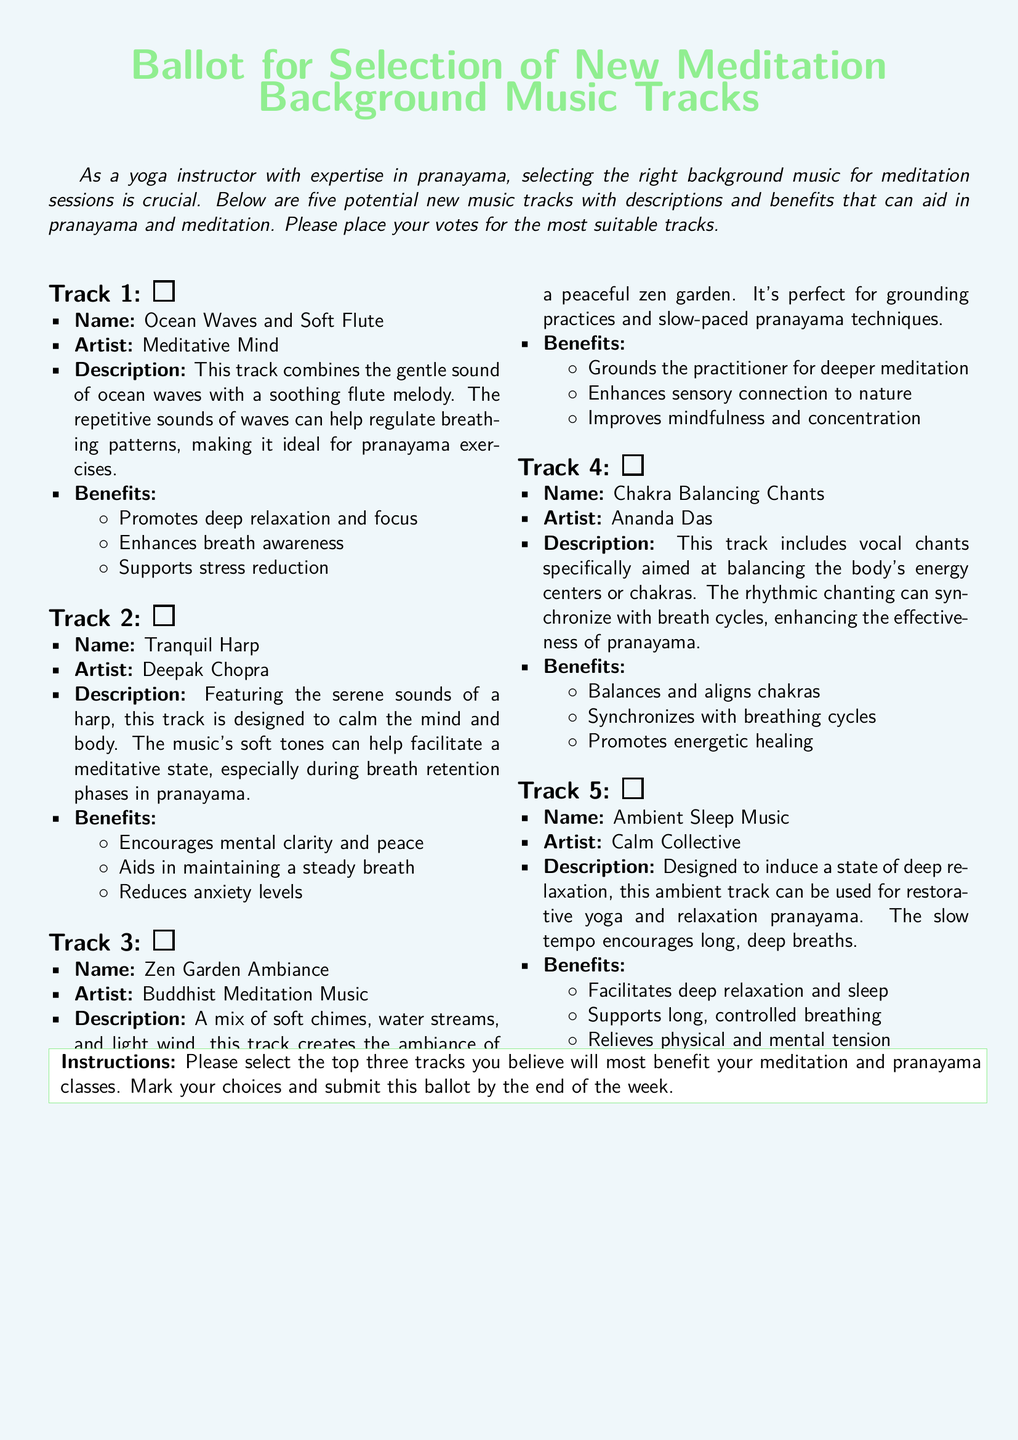What is the title of the document? The title is displayed prominently at the top of the document.
Answer: Ballot for Selection of New Meditation Background Music Tracks How many tracks are listed for selection? The document contains a count of tracks specified in the descriptions.
Answer: Five What is the name of the artist for Track 3? The artist's name for each track is provided in its description.
Answer: Buddhist Meditation Music Which track features vocal chants? The description of each track indicates the one with vocal chants.
Answer: Chakra Balancing Chants What is a benefit of Track 5? The benefits associated with each track are listed below their descriptions.
Answer: Facilitates deep relaxation and sleep Which track combines ocean waves with a flute melody? The name and description of each track state its unique attributes.
Answer: Ocean Waves and Soft Flute What color is the background of the document? The document mentions the background color in the formatting section.
Answer: Yogablue What is the instruction for submitting the ballot? The specific instructions for how to submit the ballot are provided in the instructions section.
Answer: By the end of the week 